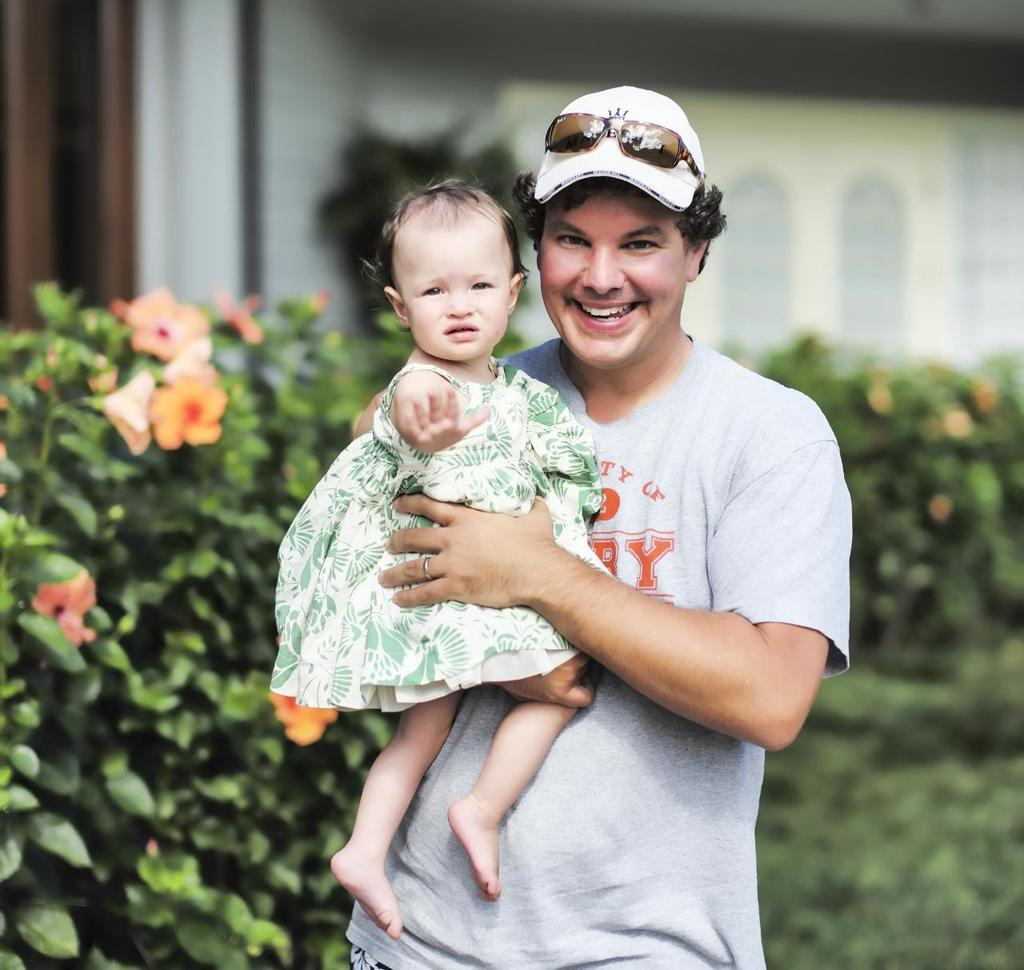What is the man in the image doing? The man is standing and carrying a girl. What is the man's facial expression in the image? The man is smiling. What can be seen behind the man in the image? There are plants visible behind the man. How would you describe the background of the image? The background of the image is blurred. What type of noise can be heard coming from the egg in the image? There is no egg present in the image, so it is not possible to determine what, if any, noise might be heard. 